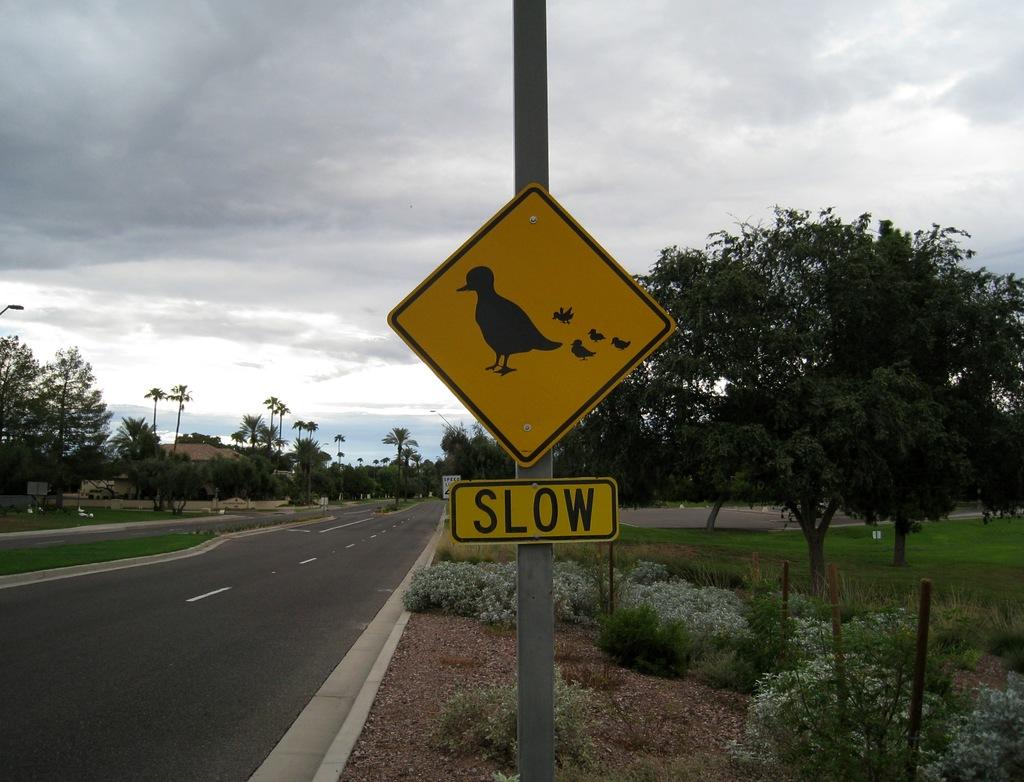What does this sign advise drivers to do?
Offer a very short reply. Slow. What does the sign warn drivers of?
Offer a very short reply. Ducks. 